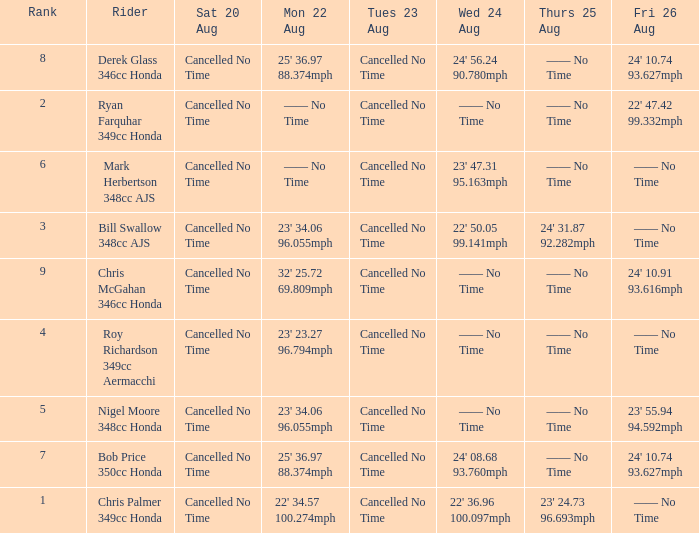What is every entry on Monday August 22 when the entry for Wednesday August 24 is 22' 50.05 99.141mph? 23' 34.06 96.055mph. 